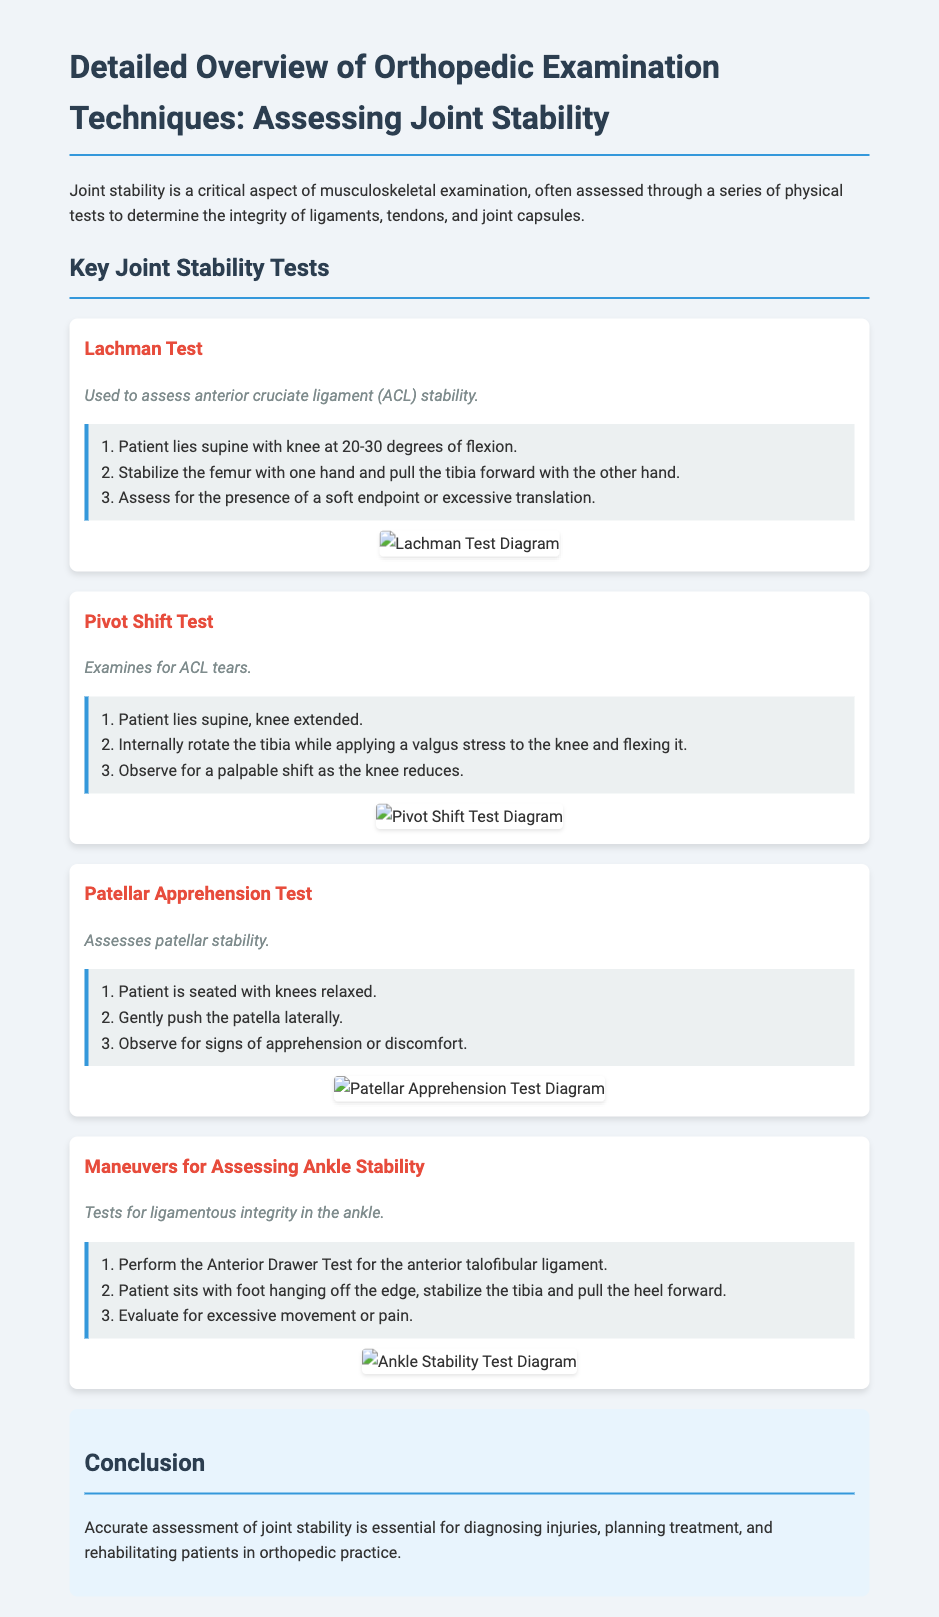What is the purpose of the Lachman Test? The Lachman Test is used to assess anterior cruciate ligament (ACL) stability.
Answer: ACL stability What position should the patient be in for the Pivot Shift Test? The patient should lie supine with the knee extended for the Pivot Shift Test.
Answer: Supine with knee extended How many steps are listed for the Patellar Apprehension Test? There are three steps listed for the Patellar Apprehension Test.
Answer: Three steps What does the Anterior Drawer Test evaluate? The Anterior Drawer Test evaluates the anterior talofibular ligament.
Answer: Anterior talofibular ligament Which section concludes the document? The section that concludes the document is titled "Conclusion."
Answer: Conclusion What is the main goal of assessing joint stability? The main goal is for diagnosing injuries, planning treatment, and rehabilitating patients in orthopedic practice.
Answer: Diagnosing injuries, planning treatment, and rehabilitating patients What is the color of the heading for each test? The color of the heading for each test is red.
Answer: Red What should be observed during the Patellar Apprehension Test? Signs of apprehension or discomfort should be observed during the test.
Answer: Apprehension or discomfort 